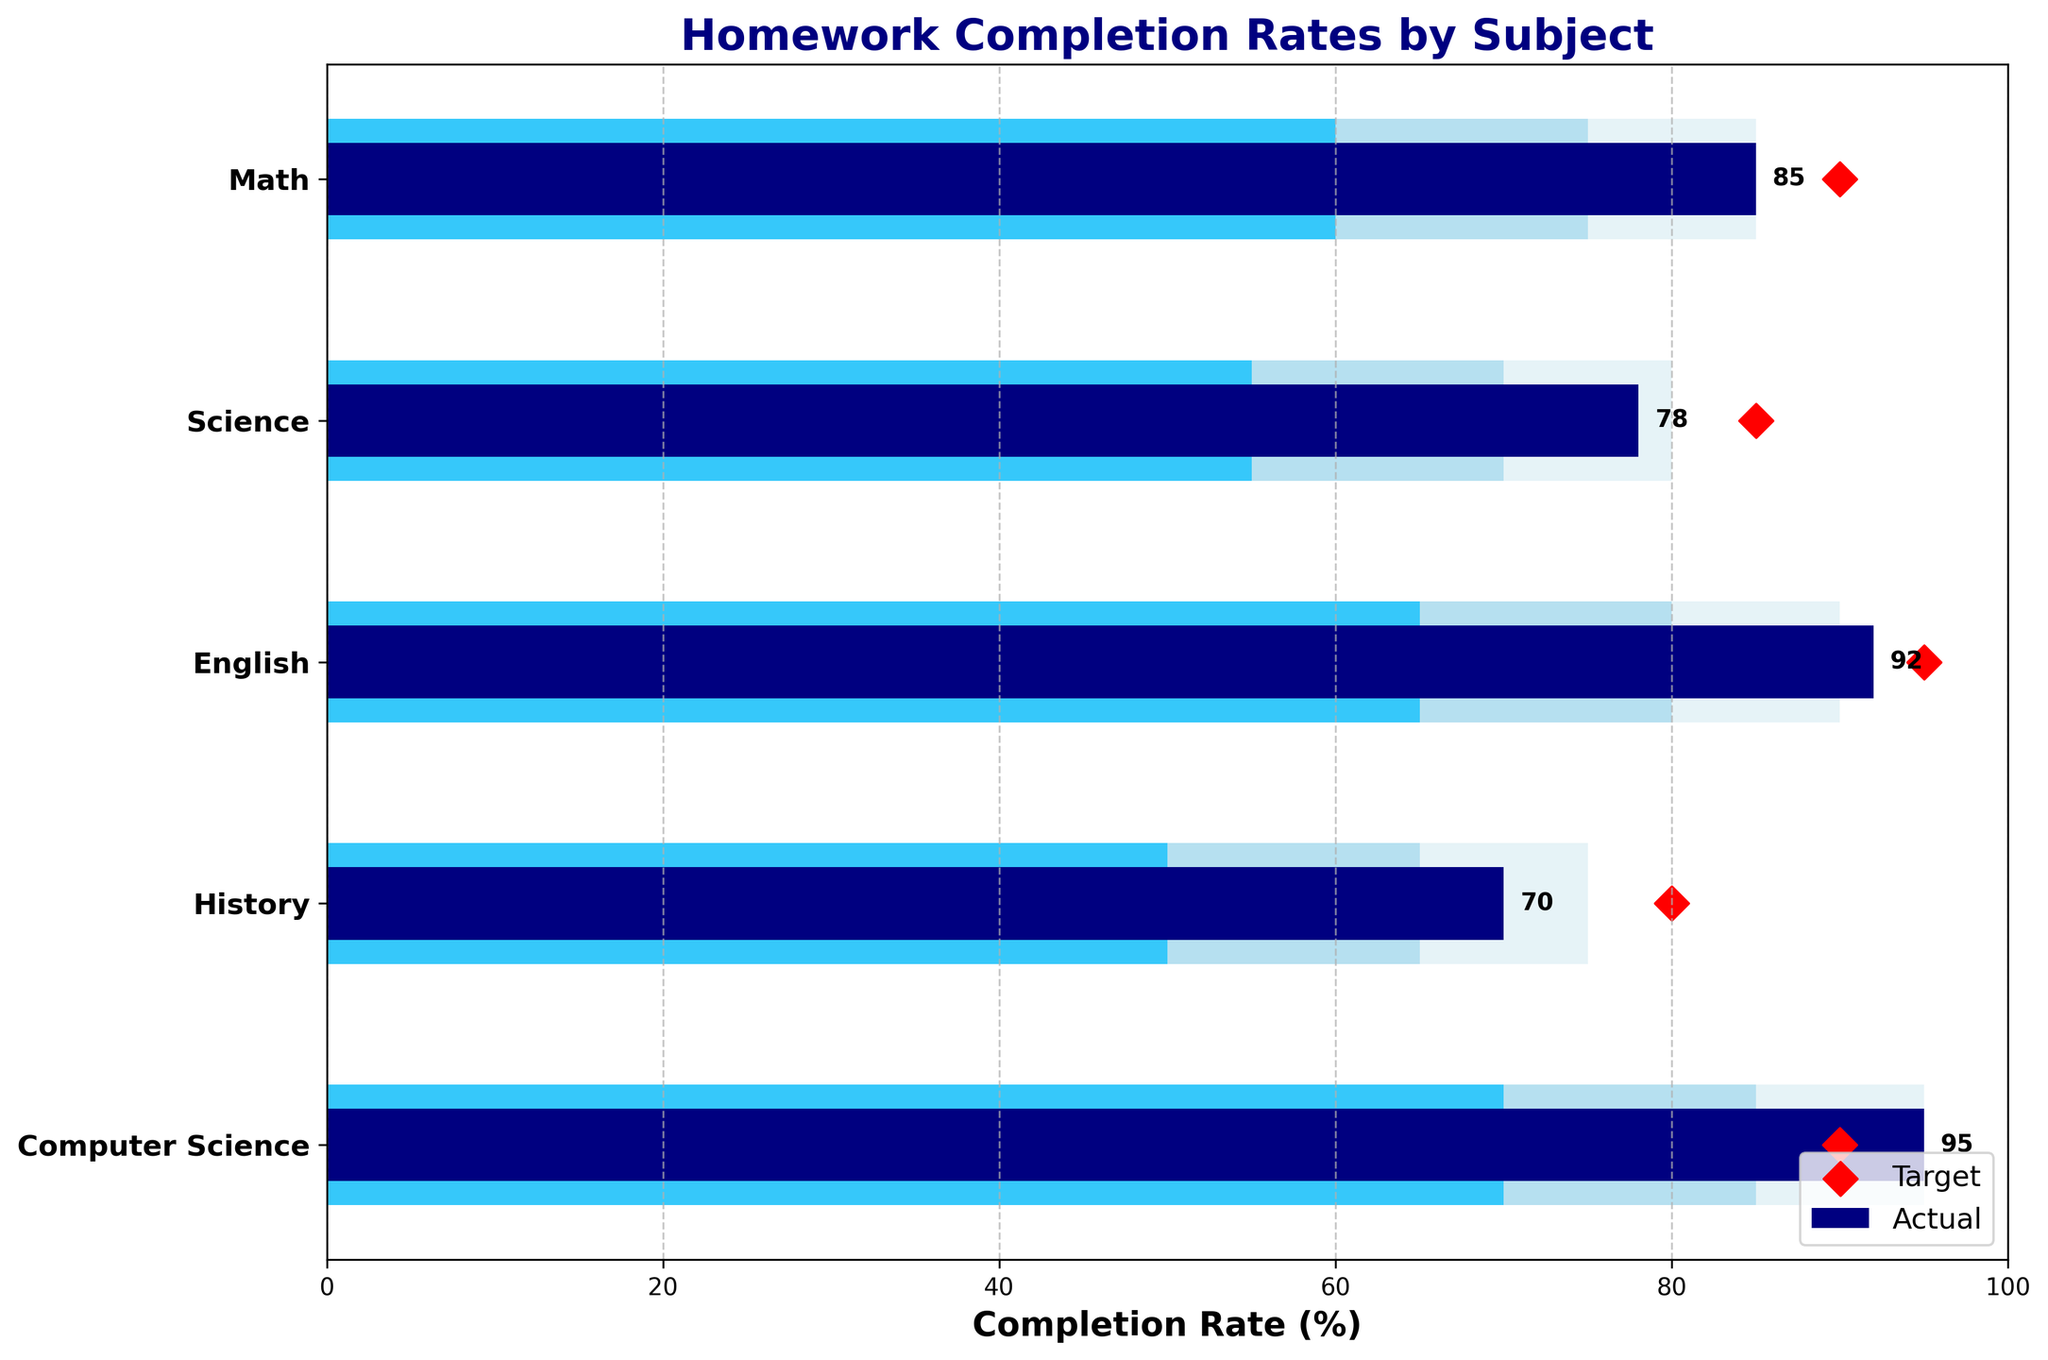What is the title of the figure? The title of the figure is displayed at the top of the chart and provides the main topic or focus of the visualization.
Answer: Homework Completion Rates by Subject Which subject has the highest actual completion rate? The actual completion rates are shown as navy bars. The subject with the highest bar represents the highest actual completion rate.
Answer: Computer Science What is the target completion rate for Math? The target rates are shown as red diamonds. The corresponding value next to the Math label represents the target completion rate for this subject.
Answer: 90 How many subjects met or exceeded their target completion rates? We need to identify subjects where the navy bar (actual completion) is greater than or equal to the red diamond (target completion). Subjects: Maths, English, and Computer Science.
Answer: 3 What is the difference between the actual and target completion rates for History? Subtract the target rate from the actual rate for History by looking at the values shown in the chart. Calculation: 70 - 80 = -10.
Answer: -10 Which subject has the lowest actual completion rate? The actual completion rates are shown as navy bars. The subject with the shortest bar represents the lowest actual completion rate.
Answer: History Compare the actual completion rates for Science and English. Which one is higher? Look at the navy bars for Science and English. The height of the English bar is higher, indicating a higher completion rate.
Answer: English What is the range of completion rates considered excellent for Computer Science? The third range is shown in light blue, and for Computer Science, it spans from 70 to 95.
Answer: 70-95 How many subjects have actual completion rates above their first range but below their target? Check the actual completion rates (navy bars), compare them to the first range and target. Subjects: Math, Science, History.
Answer: 3 Does any subject have an actual completion rate equal to its target rate? Compare the top of the navy bars to the red diamonds. For Computer Science, the actual rate is 95, which matches the target rate of 90.
Answer: Yes 